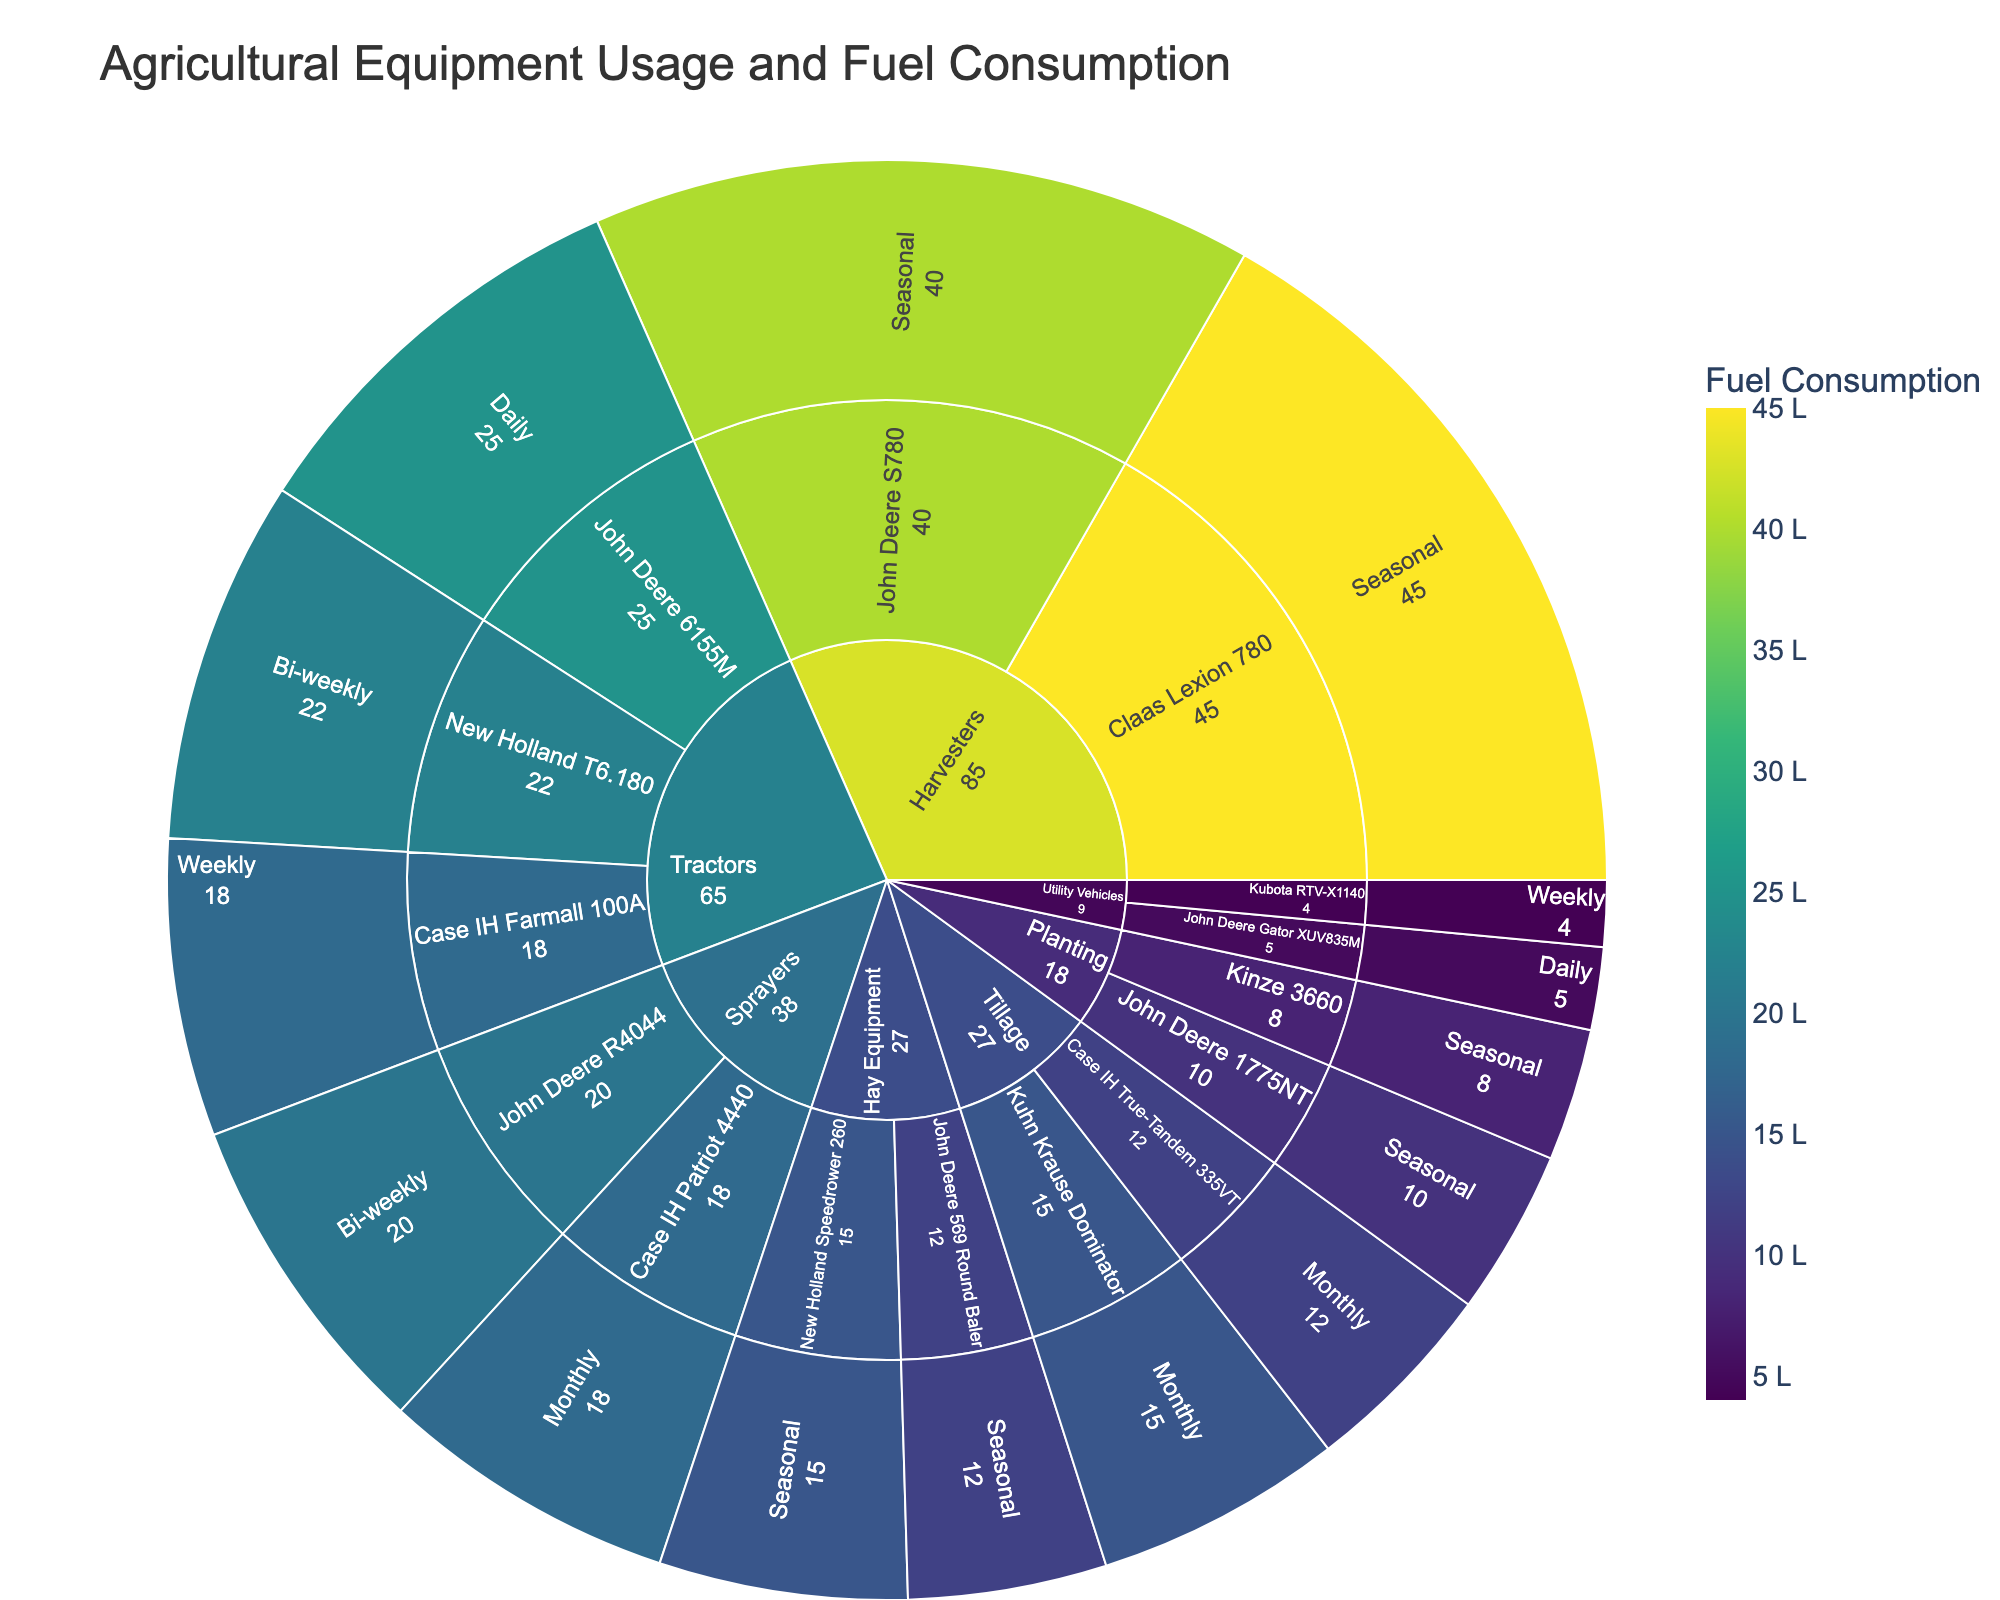How is "Agricultural Equipment Usage and Fuel Consumption" categorized? The sunburst plot categorizes equipment first by type (e.g., Tractors, Harvesters), then by specific equipment names (e.g., John Deere 6155M, Claas Lexion 780), and finally by frequency of usage (e.g., Daily, Weekly).
Answer: By type, equipment, and frequency What is the title of the sunburst plot? The title of the sunburst plot is displayed at the top center.
Answer: Agricultural Equipment Usage and Fuel Consumption Which equipment category has the highest fuel consumption for a single piece of equipment? The sunburst section with the highest individual fuel consumption is observed under the Harvesters category, specifically for the "Claas Lexion 780", which consumes 45 liters.
Answer: Harvesters How much fuel does the "John Deere 6155M" consume daily? By looking at the section for "John Deere 6155M" under Tractors and its corresponding frequency level, the fuel consumption is shown.
Answer: 25 liters Which has a higher total fuel consumption: "John Deere" equipment or "Case IH" equipment across all categories? Sum the fuel consumption for all equipment from each brand:
- John Deere: 25 (6155M) + 40 (S780) + 10 (1775NT) + 20 (R4044) + 12 (569 Round Baler) + 5 (Gator XUV835M) = 112 liters
- Case IH: 18 (Farmall 100A) + 12 (True-Tandem 335VT) + 18 (Patriot 4440) = 48 liters
John Deere has a higher consumption.
Answer: John Deere Which category and equipment are used bi-weekly, and how much fuel do they consume? The plot shows that under "Tractors" and "Sprayers", New Holland T6.180 and John Deere R4044 are used bi-weekly. Their fuel consumptions are 22 liters and 20 liters, respectively.
Answer: New Holland T6.180 (22 liters) and John Deere R4044 (20 liters) What is the combined fuel consumption of all equipment that is used weekly? Add up the fuel consumption for equipment used weekly:
- Case IH Farmall 100A: 18 liters
- Kubota RTV-X1140: 4 liters
18 + 4 = 22 liters.
Answer: 22 liters Which category contains the most pieces of equipment in the plot? The number of pieces of equipment listed under each category can be counted. Tractors have three pieces of equipment, which is the highest among all categories.
Answer: Tractors When comparing "John Deere" and "Kinze" under the Planting category, which uses less fuel? Kinze 3660 consumes 8 liters and John Deere 1775NT consumes 10 liters. Kinze consumes less fuel.
Answer: Kinze What is the average fuel consumption of equipment categorized under "Tillage"? The fuel consumption values under Tillage are 15 and 12 liters. Their average is calculated as (15 + 12) / 2 = 13.5 liters.
Answer: 13.5 liters 